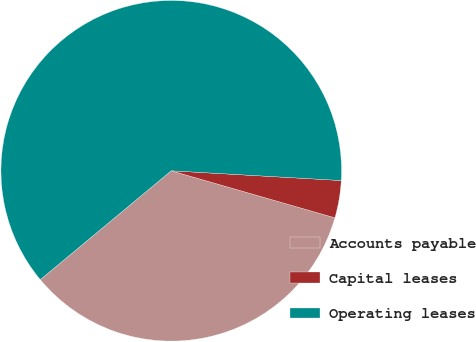Convert chart to OTSL. <chart><loc_0><loc_0><loc_500><loc_500><pie_chart><fcel>Accounts payable<fcel>Capital leases<fcel>Operating leases<nl><fcel>34.51%<fcel>3.54%<fcel>61.95%<nl></chart> 